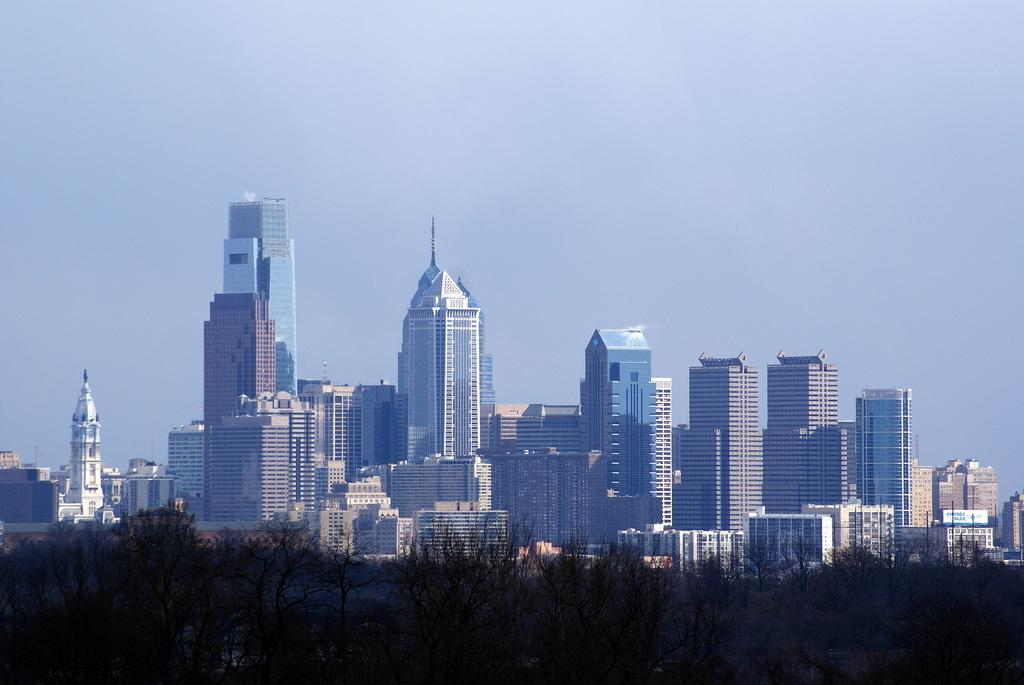What type of structures can be seen in the image? There are buildings and towers in the image. What other natural elements are present in the image? There is a group of trees in the image. What is visible in the background of the image? The sky is visible in the image. How would you describe the weather based on the sky in the image? The sky appears to be cloudy in the image. What type of blood vessels can be seen in the image? There are no blood vessels present in the image; it features buildings, towers, trees, and a cloudy sky. What type of cabbage is being harvested in the image? There is no cabbage present in the image. 